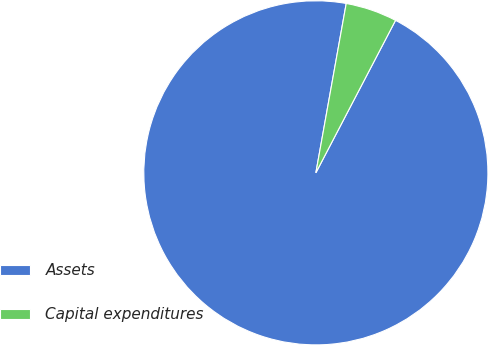<chart> <loc_0><loc_0><loc_500><loc_500><pie_chart><fcel>Assets<fcel>Capital expenditures<nl><fcel>95.16%<fcel>4.84%<nl></chart> 